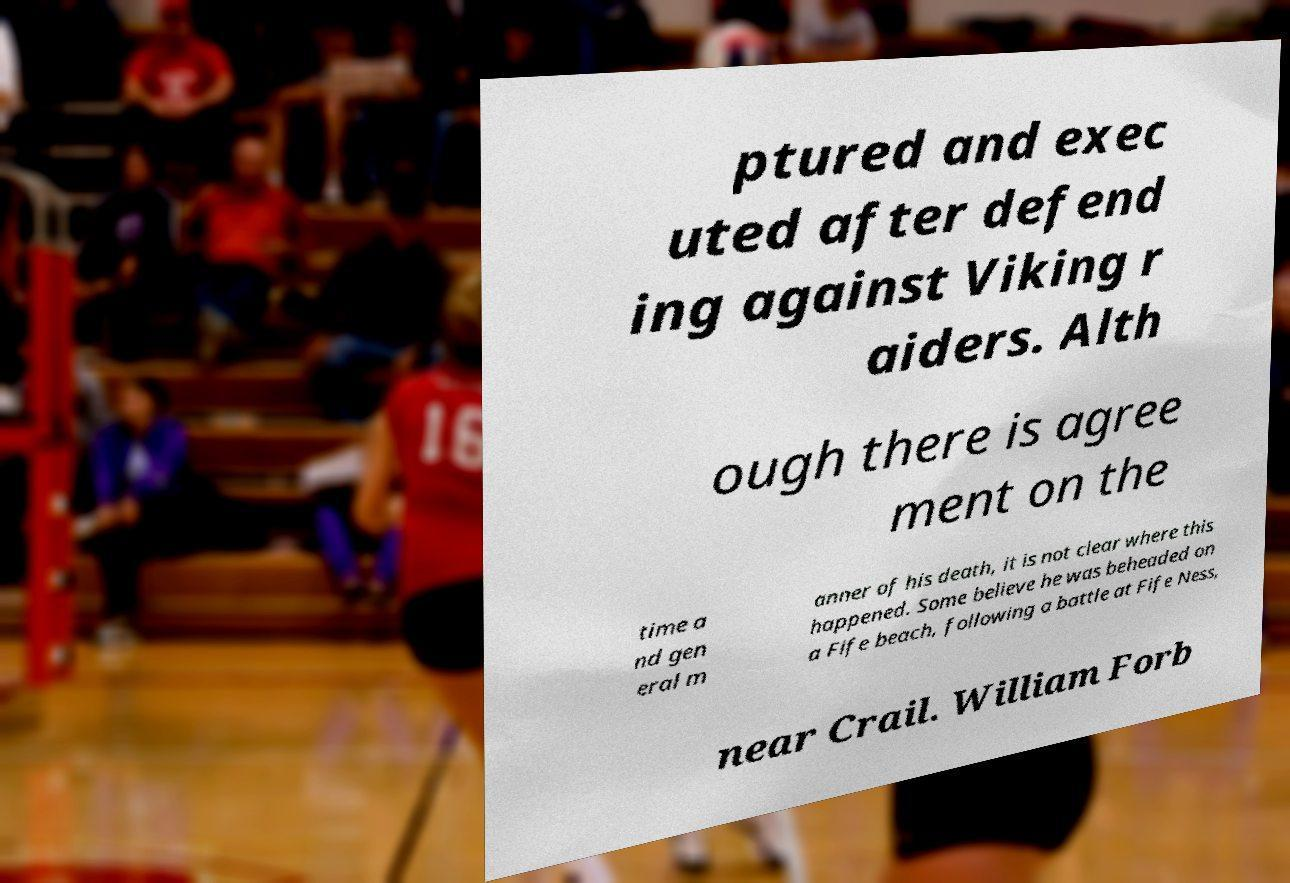Please identify and transcribe the text found in this image. ptured and exec uted after defend ing against Viking r aiders. Alth ough there is agree ment on the time a nd gen eral m anner of his death, it is not clear where this happened. Some believe he was beheaded on a Fife beach, following a battle at Fife Ness, near Crail. William Forb 